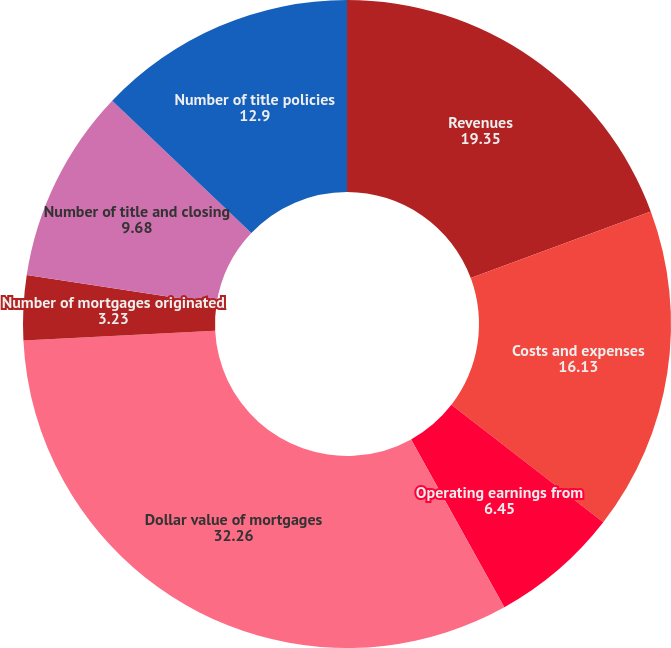Convert chart. <chart><loc_0><loc_0><loc_500><loc_500><pie_chart><fcel>Revenues<fcel>Costs and expenses<fcel>Operating earnings from<fcel>Dollar value of mortgages<fcel>Number of mortgages originated<fcel>Mortgage capture rate of<fcel>Number of title and closing<fcel>Number of title policies<nl><fcel>19.35%<fcel>16.13%<fcel>6.45%<fcel>32.26%<fcel>3.23%<fcel>0.0%<fcel>9.68%<fcel>12.9%<nl></chart> 